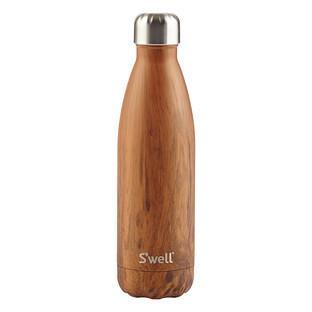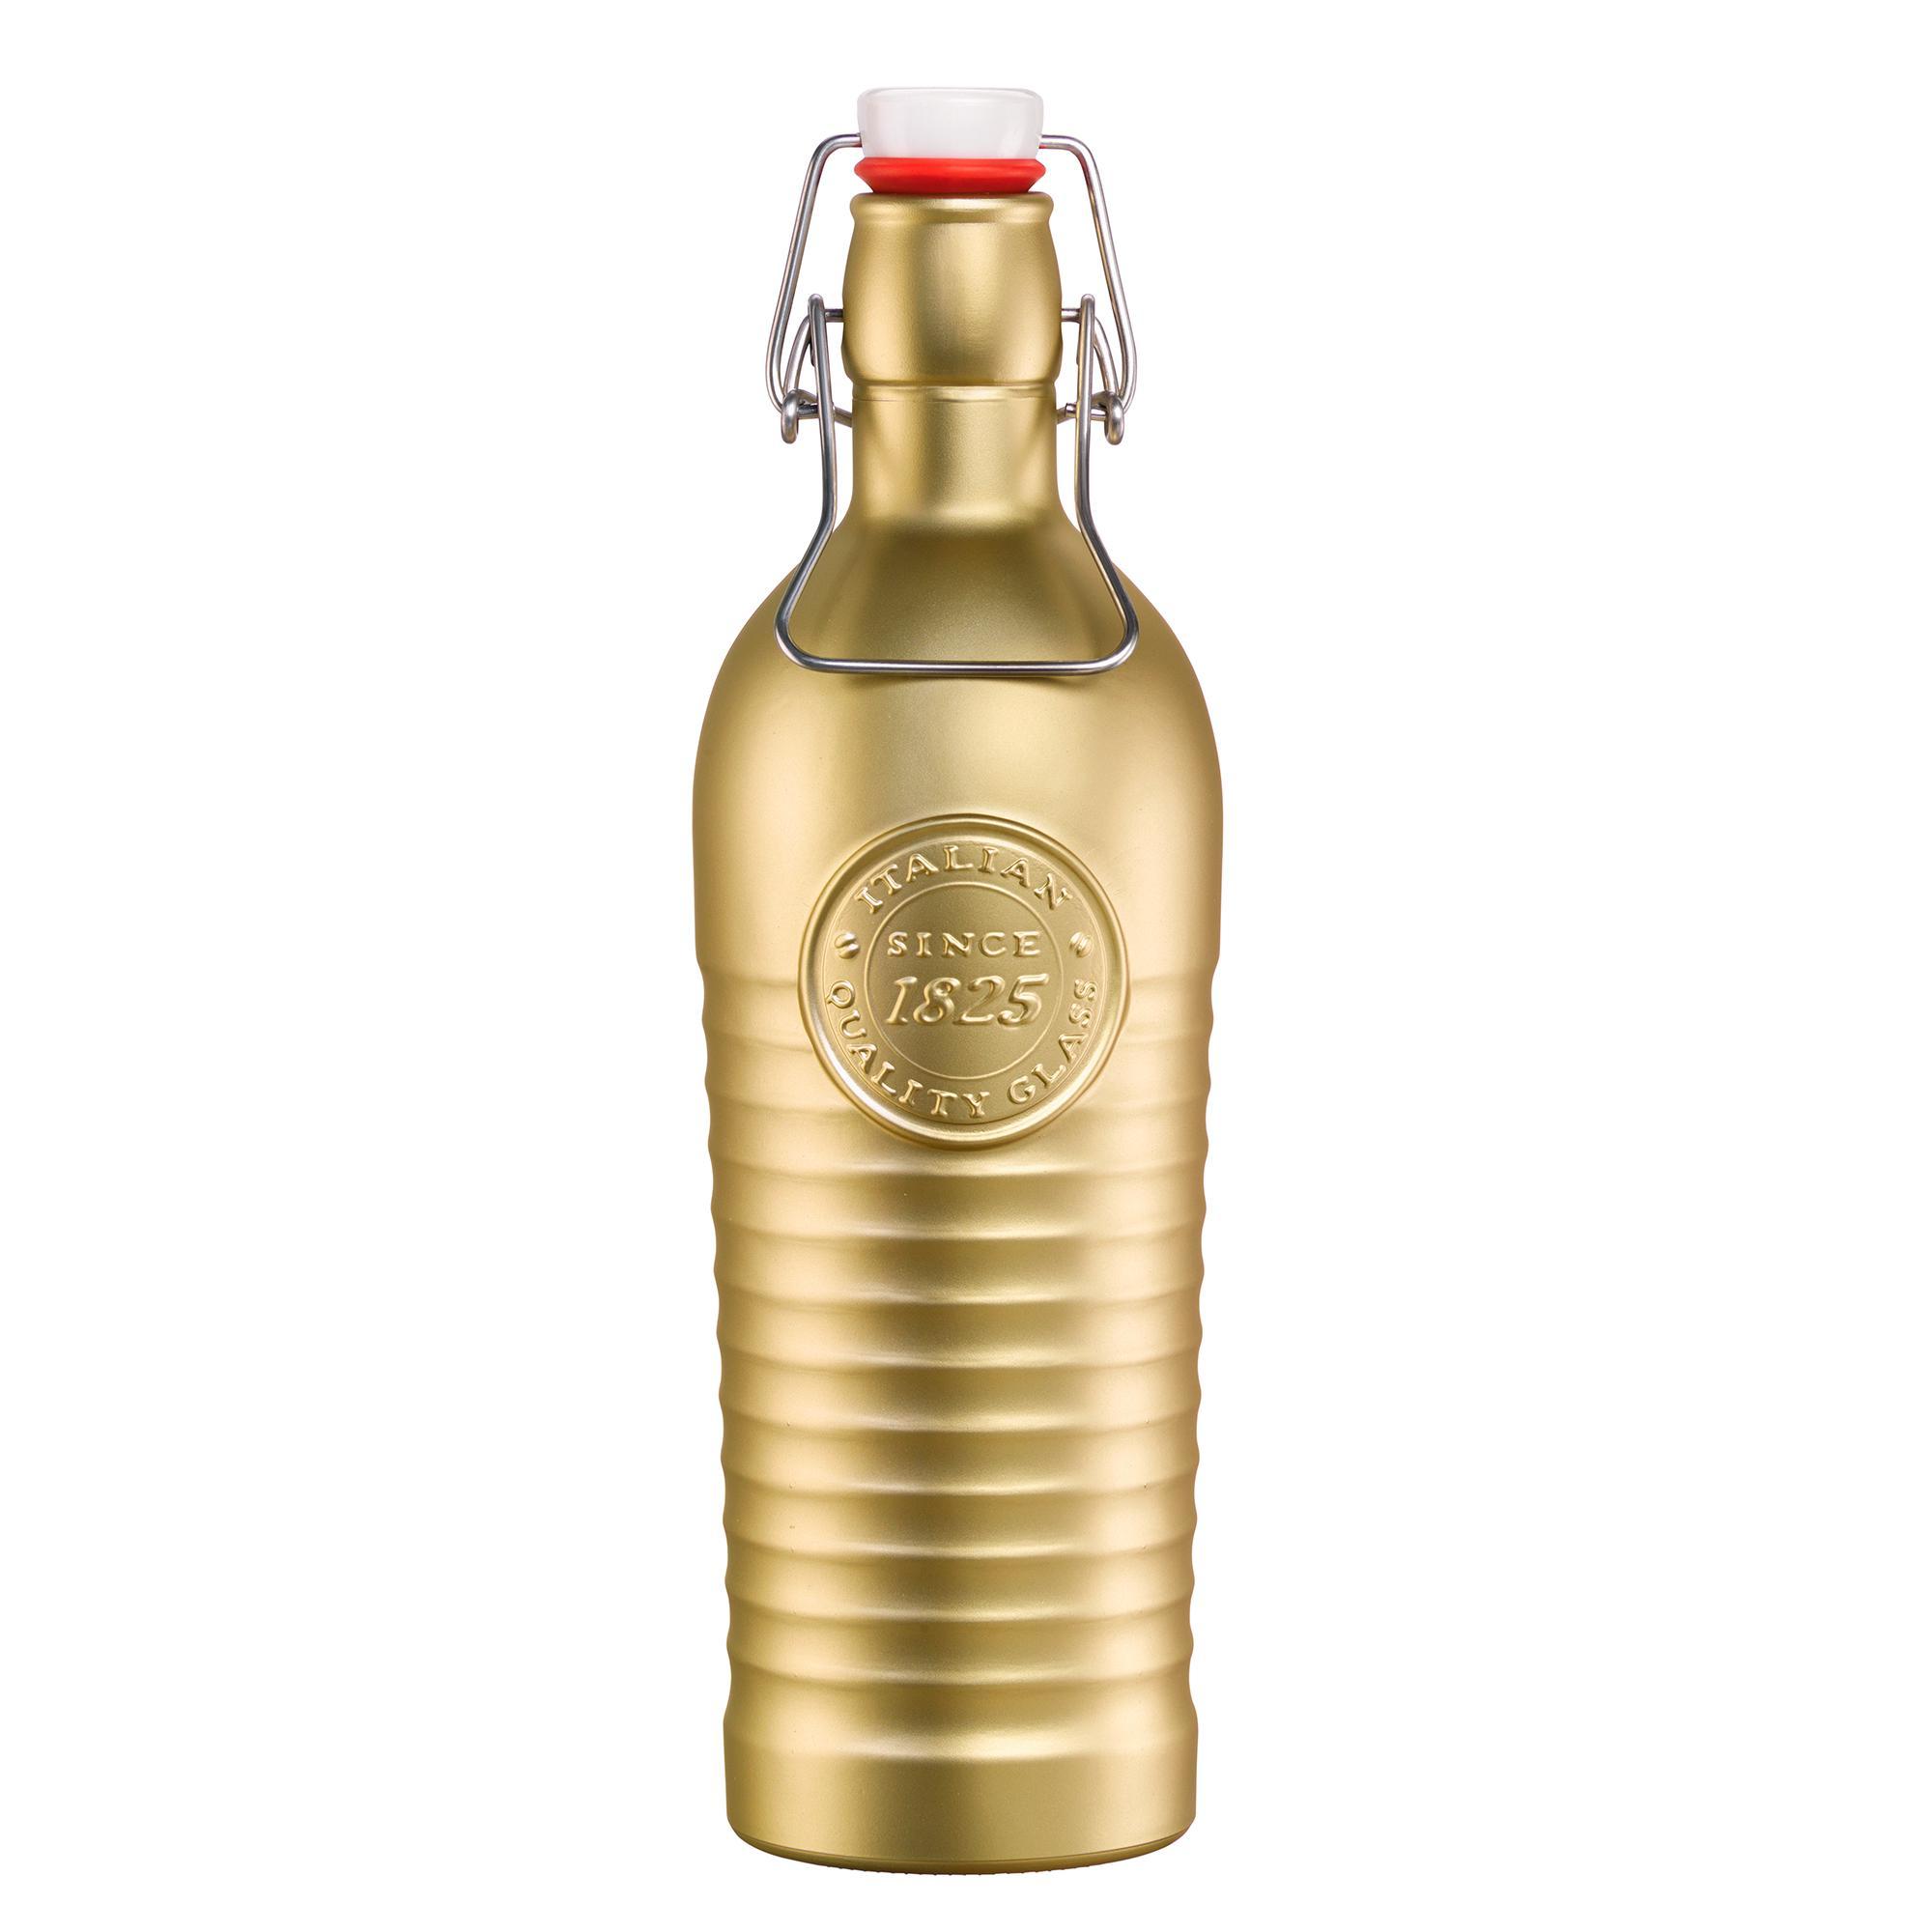The first image is the image on the left, the second image is the image on the right. Considering the images on both sides, is "the bottle on the left image has a wooden look" valid? Answer yes or no. Yes. 